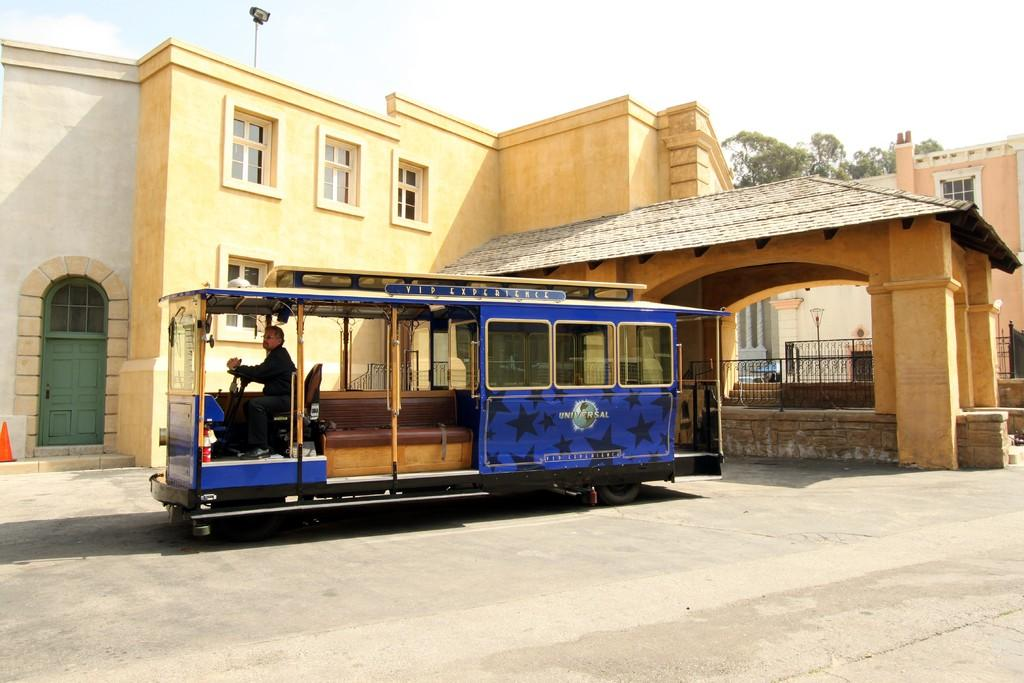What is the main structure in the image? There is a building in the image. What is located in front of the building? There is a vehicle in front of the building. What can be seen in the background of the image? There is a tree and the sky visible in the background of the image. What type of feast is being held in front of the building in the image? There is no feast present in the image; it only shows a building and a vehicle in front of it. 